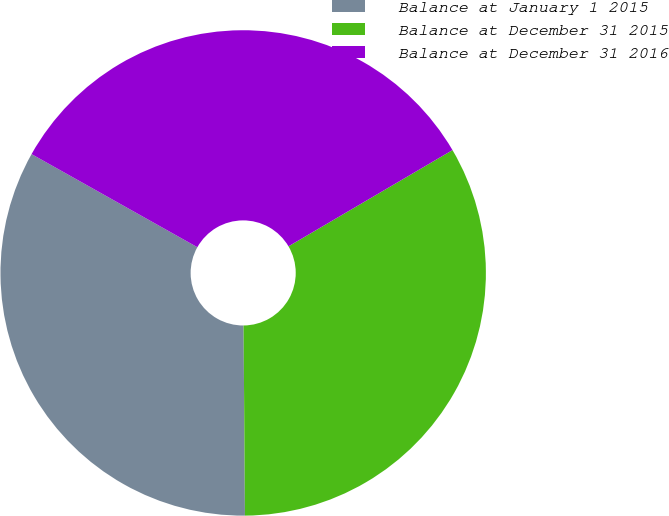Convert chart to OTSL. <chart><loc_0><loc_0><loc_500><loc_500><pie_chart><fcel>Balance at January 1 2015<fcel>Balance at December 31 2015<fcel>Balance at December 31 2016<nl><fcel>33.26%<fcel>33.33%<fcel>33.41%<nl></chart> 